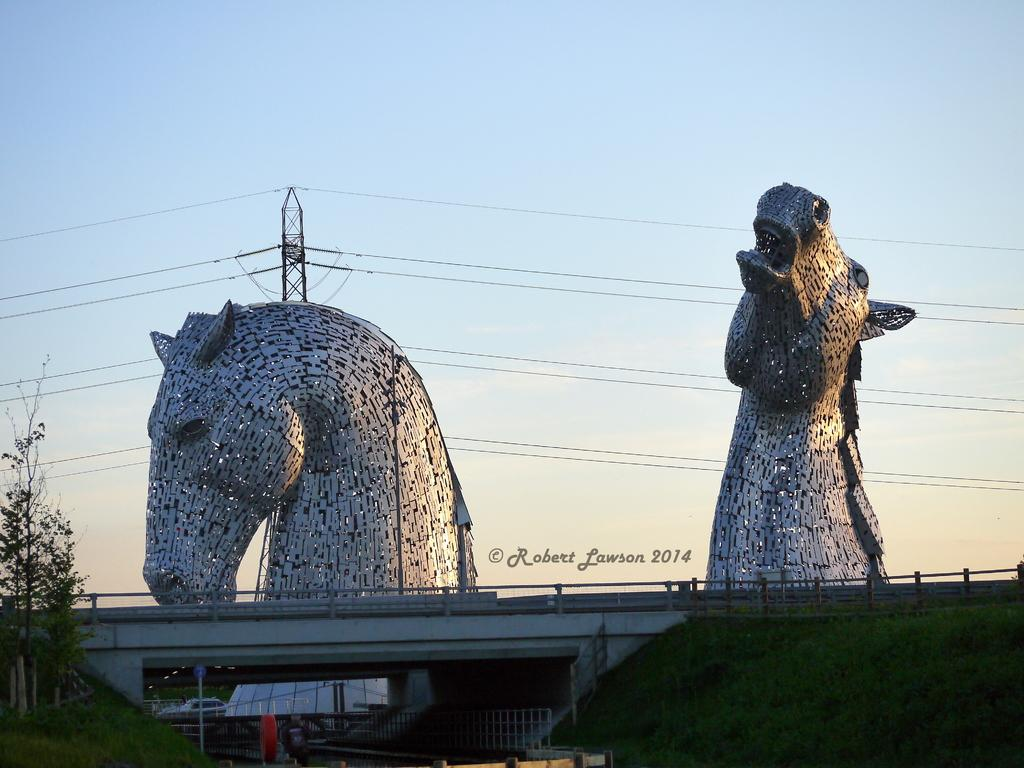What can be seen in the sky in the image? The sky is visible in the image, but no specific details about the sky are mentioned in the facts. What structure is present with wires in the image? There is a tower with wires in the image. How many statues are in the image? There are two statues in the image. What is the purpose of the watermark in the image? The purpose of the watermark is not mentioned in the facts. What type of structure is this in the image? This is a bridge in the image. What type of vegetation is present in the image? There is grass in the image, and there is also a tree present. What safety feature is visible in the image? There is a railing in the image. What type of news can be heard coming from the jar in the image? There is no jar present in the image, and therefore no news can be heard from it. Can you describe the kiss between the two statues in the image? There are no statues kissing in the image; they are simply standing. 